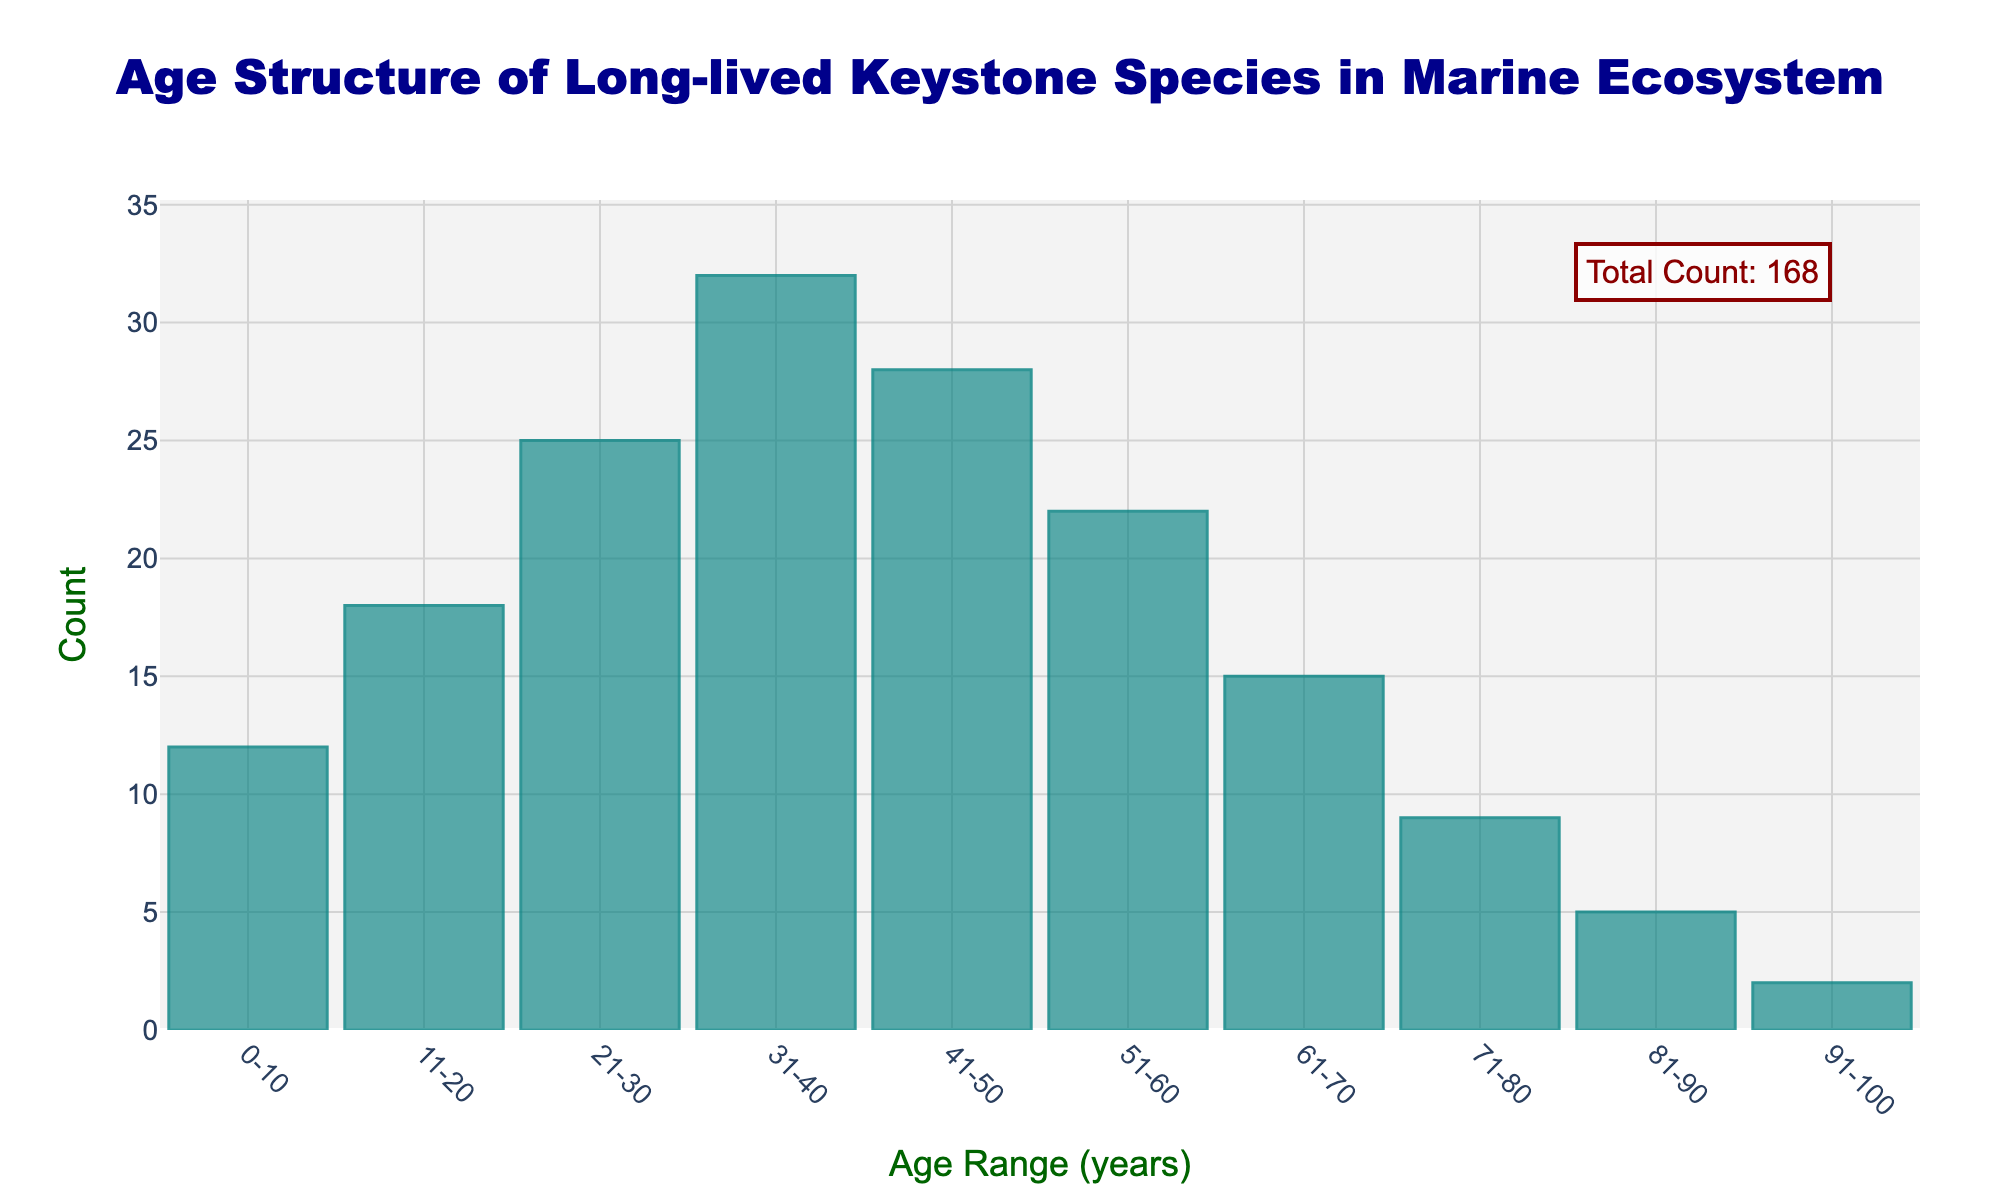What is the title of the figure? The title is displayed prominently at the top of the figure in a large, dark blue font. By reading the text, we can identify the title.
Answer: Age Structure of Long-lived Keystone Species in Marine Ecosystem What are the x-axis and y-axis titles? The titles for the axes are shown beside the x-axis and y-axis in dark green fonts. By reading these labels, we can determine the x-axis is labeled "Age Range (years)" and the y-axis is labeled "Count".
Answer: Age Range (years) and Count Which age range has the highest count? The age range with the highest count is easily observed by finding the tallest bar in the histogram. The bar for the age range 31-40 is the tallest.
Answer: 31-40 What is the total count of the species? The total count of the species is explicitly provided as an annotation in the upper right corner of the plot. By reading this annotation, we find the total count is 168.
Answer: 168 How many age ranges are depicted in the histogram? The number of age ranges can be counted by counting the number of bars on the x-axis. There are 10 bars in total.
Answer: 10 What is the difference in count between the age ranges 41-50 and 61-70? Find the bar corresponding to 41-50 (count = 28) and the bar for 61-70 (count = 15). Subtract the smaller value from the larger value to get the difference: 28 - 15 = 13.
Answer: 13 Which age range has a count closest to the median count value for all age ranges? To find the median count, first, list all counts in ascending order: 2, 5, 9, 12, 15, 18, 22, 25, 28, 32. The median is the middle value (or the average of the two middle values), which is (22+25)/2 = 23.5. The closest count to 23.5 is 22 (age range 51-60).
Answer: 51-60 How does the count for the age range 71-80 compare to the count for the age range 21-30? The count for 71-80 is 9, and the count for 21-30 is 25. By comparing these numbers, 25 is greater than 9.
Answer: The count for 21-30 is higher What trends do you observe in the age structure histogram? Observing the histogram, one can identify that the count increases until the age range 31-40, peaking there, and then gradually decreases. This pattern suggests a higher population in the middle age ranges and a lower population in the youngest and oldest age ranges.
Answer: Count increases to a peak at 31-40, then decreases What is the combined count for the age ranges above 60 years? Adding the counts for the age ranges 61-70 (15), 71-80 (9), 81-90 (5), and 91-100 (2) results in 15 + 9 + 5 + 2 = 31.
Answer: 31 